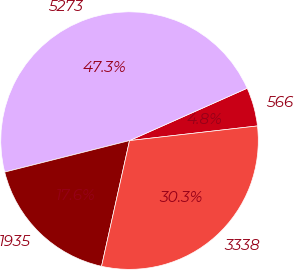Convert chart. <chart><loc_0><loc_0><loc_500><loc_500><pie_chart><fcel>566<fcel>5273<fcel>1935<fcel>3338<nl><fcel>4.85%<fcel>47.27%<fcel>17.58%<fcel>30.3%<nl></chart> 